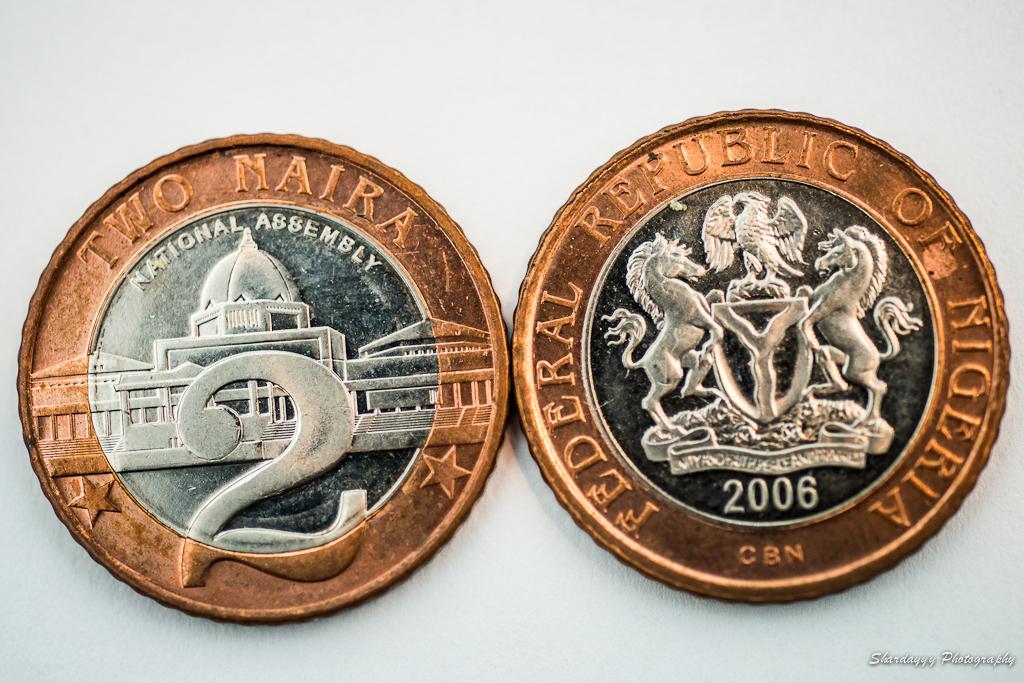When was this coin issued?
Make the answer very short. 2006. 